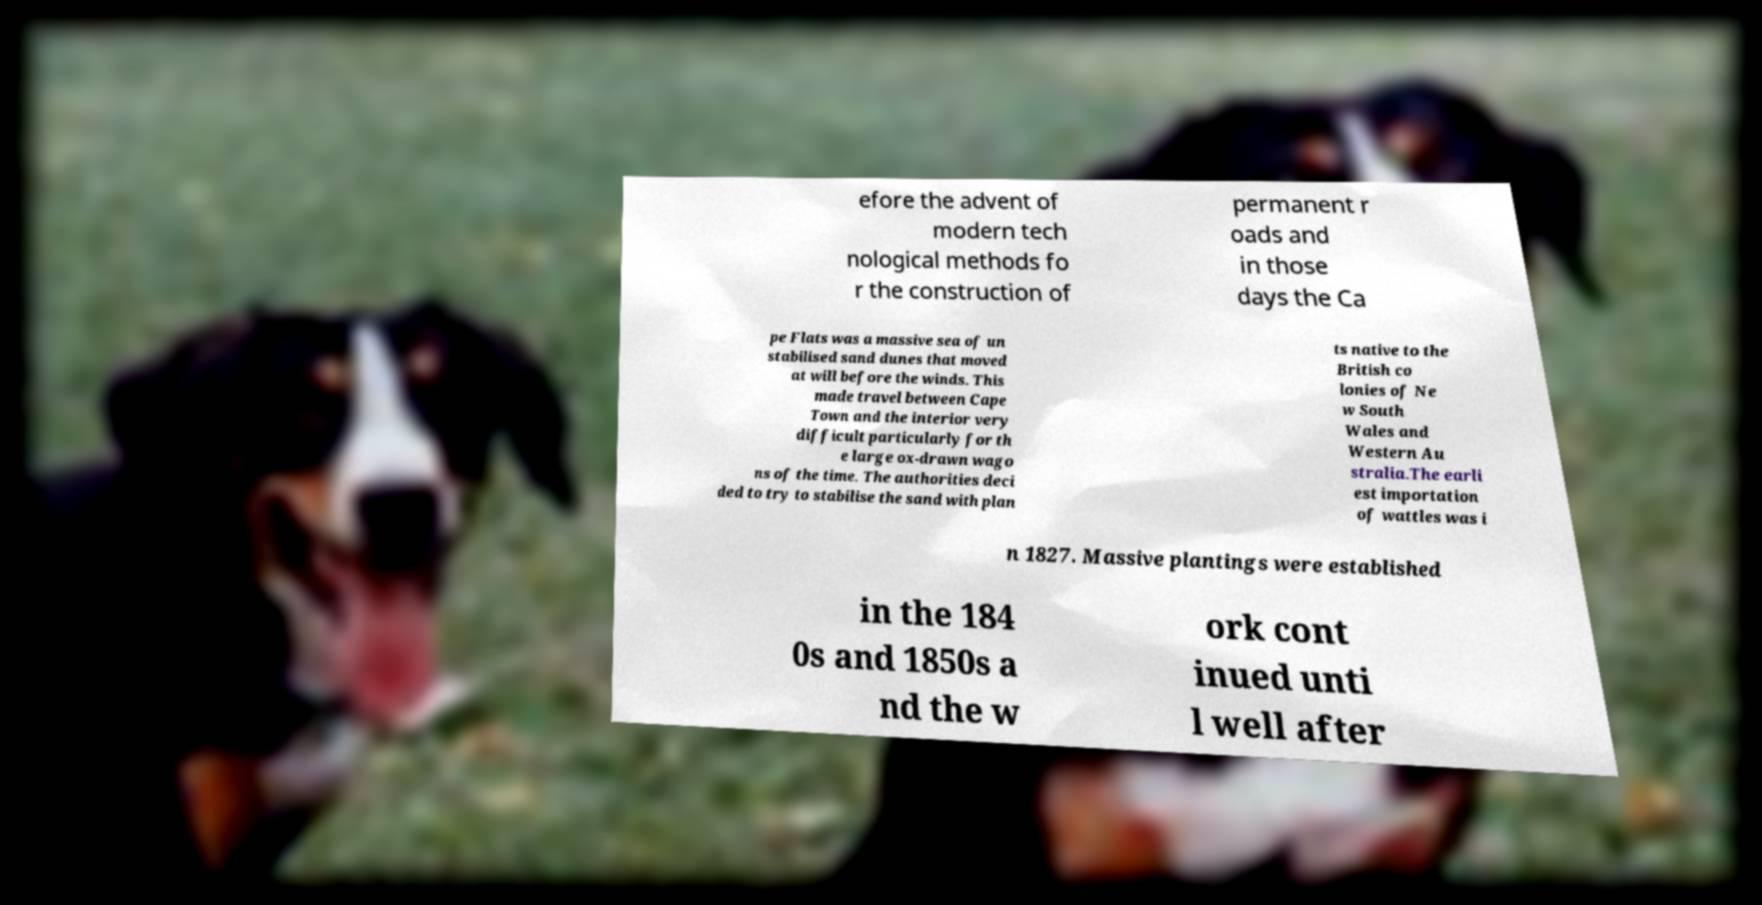What messages or text are displayed in this image? I need them in a readable, typed format. efore the advent of modern tech nological methods fo r the construction of permanent r oads and in those days the Ca pe Flats was a massive sea of un stabilised sand dunes that moved at will before the winds. This made travel between Cape Town and the interior very difficult particularly for th e large ox-drawn wago ns of the time. The authorities deci ded to try to stabilise the sand with plan ts native to the British co lonies of Ne w South Wales and Western Au stralia.The earli est importation of wattles was i n 1827. Massive plantings were established in the 184 0s and 1850s a nd the w ork cont inued unti l well after 